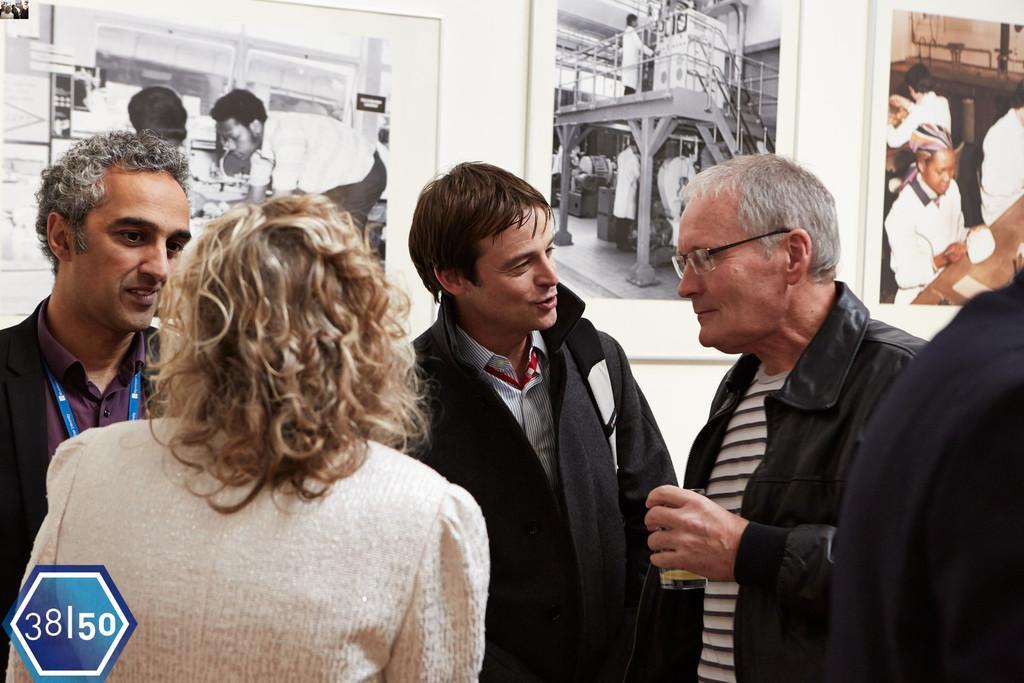How would you summarize this image in a sentence or two? In this picture we can see four persons are standing, a man on the right side is holding a glass of drink, in the background there are photo frames and a wall, we can see pictures of persons in those frames, there are numbers at the left bottom. 